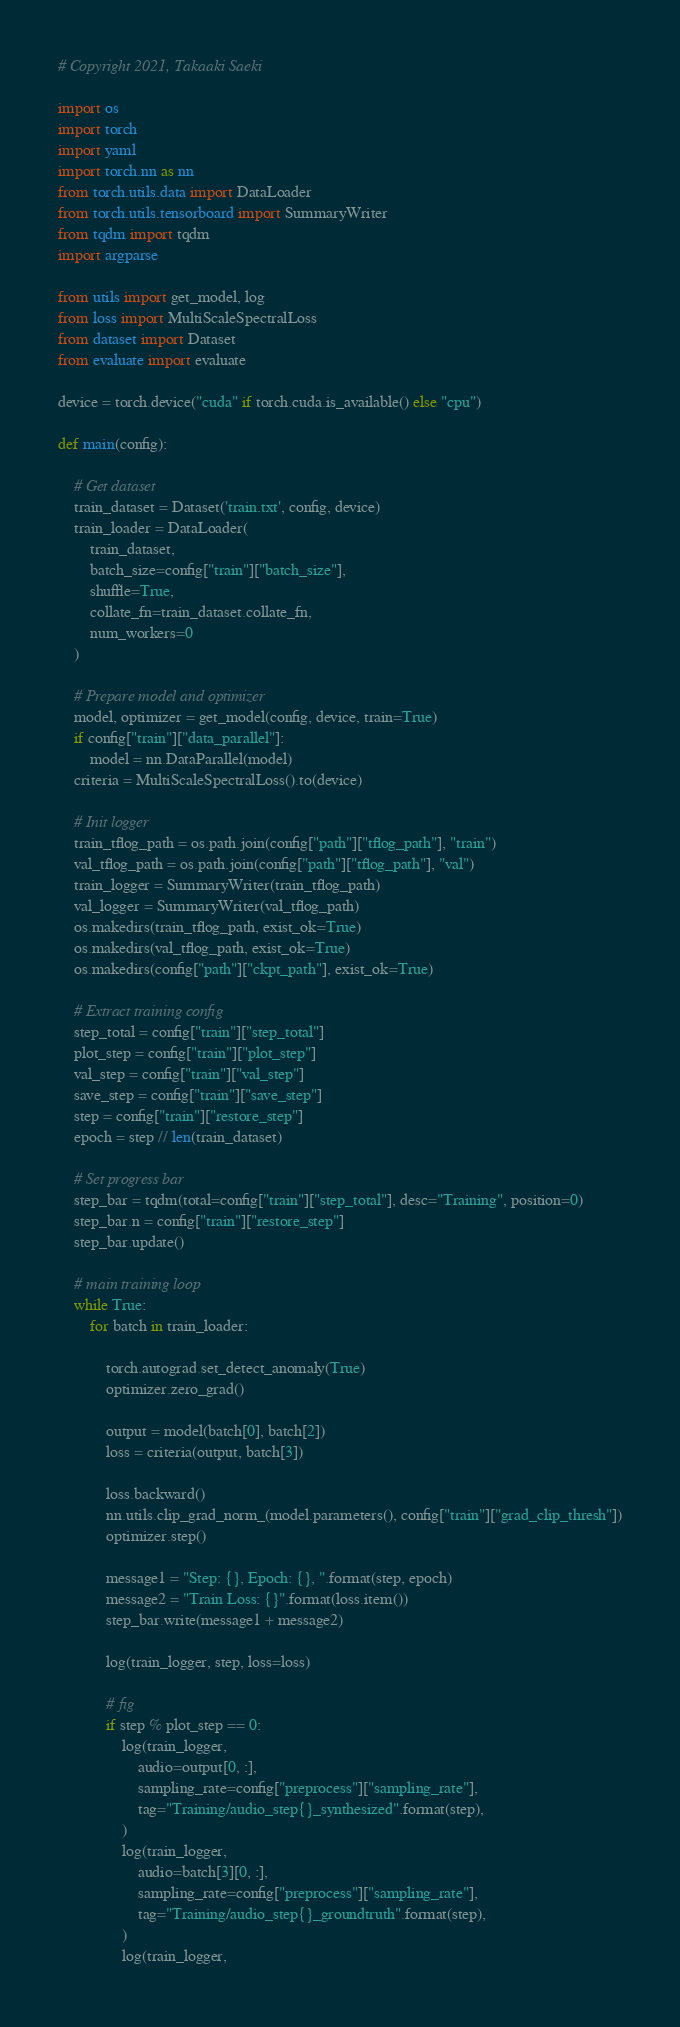<code> <loc_0><loc_0><loc_500><loc_500><_Python_># Copyright 2021, Takaaki Saeki

import os
import torch
import yaml
import torch.nn as nn
from torch.utils.data import DataLoader
from torch.utils.tensorboard import SummaryWriter
from tqdm import tqdm
import argparse

from utils import get_model, log
from loss import MultiScaleSpectralLoss
from dataset import Dataset
from evaluate import evaluate

device = torch.device("cuda" if torch.cuda.is_available() else "cpu")

def main(config):

    # Get dataset
    train_dataset = Dataset('train.txt', config, device)
    train_loader = DataLoader(
        train_dataset,
        batch_size=config["train"]["batch_size"],
        shuffle=True,
        collate_fn=train_dataset.collate_fn,
        num_workers=0
    )

    # Prepare model and optimizer
    model, optimizer = get_model(config, device, train=True)
    if config["train"]["data_parallel"]:
        model = nn.DataParallel(model)
    criteria = MultiScaleSpectralLoss().to(device)

    # Init logger
    train_tflog_path = os.path.join(config["path"]["tflog_path"], "train")
    val_tflog_path = os.path.join(config["path"]["tflog_path"], "val")
    train_logger = SummaryWriter(train_tflog_path)
    val_logger = SummaryWriter(val_tflog_path)
    os.makedirs(train_tflog_path, exist_ok=True)
    os.makedirs(val_tflog_path, exist_ok=True)
    os.makedirs(config["path"]["ckpt_path"], exist_ok=True)

    # Extract training config
    step_total = config["train"]["step_total"]
    plot_step = config["train"]["plot_step"]
    val_step = config["train"]["val_step"]
    save_step = config["train"]["save_step"]
    step = config["train"]["restore_step"]
    epoch = step // len(train_dataset)

    # Set progress bar
    step_bar = tqdm(total=config["train"]["step_total"], desc="Training", position=0)
    step_bar.n = config["train"]["restore_step"]
    step_bar.update()

    # main training loop
    while True:
        for batch in train_loader:

            torch.autograd.set_detect_anomaly(True)
            optimizer.zero_grad()

            output = model(batch[0], batch[2])
            loss = criteria(output, batch[3])

            loss.backward()
            nn.utils.clip_grad_norm_(model.parameters(), config["train"]["grad_clip_thresh"])
            optimizer.step()

            message1 = "Step: {}, Epoch: {}, ".format(step, epoch)
            message2 = "Train Loss: {}".format(loss.item())
            step_bar.write(message1 + message2)

            log(train_logger, step, loss=loss)

            # fig
            if step % plot_step == 0:
                log(train_logger,
                    audio=output[0, :],
                    sampling_rate=config["preprocess"]["sampling_rate"],
                    tag="Training/audio_step{}_synthesized".format(step),
                )
                log(train_logger,
                    audio=batch[3][0, :],
                    sampling_rate=config["preprocess"]["sampling_rate"],
                    tag="Training/audio_step{}_groundtruth".format(step),
                )
                log(train_logger,</code> 